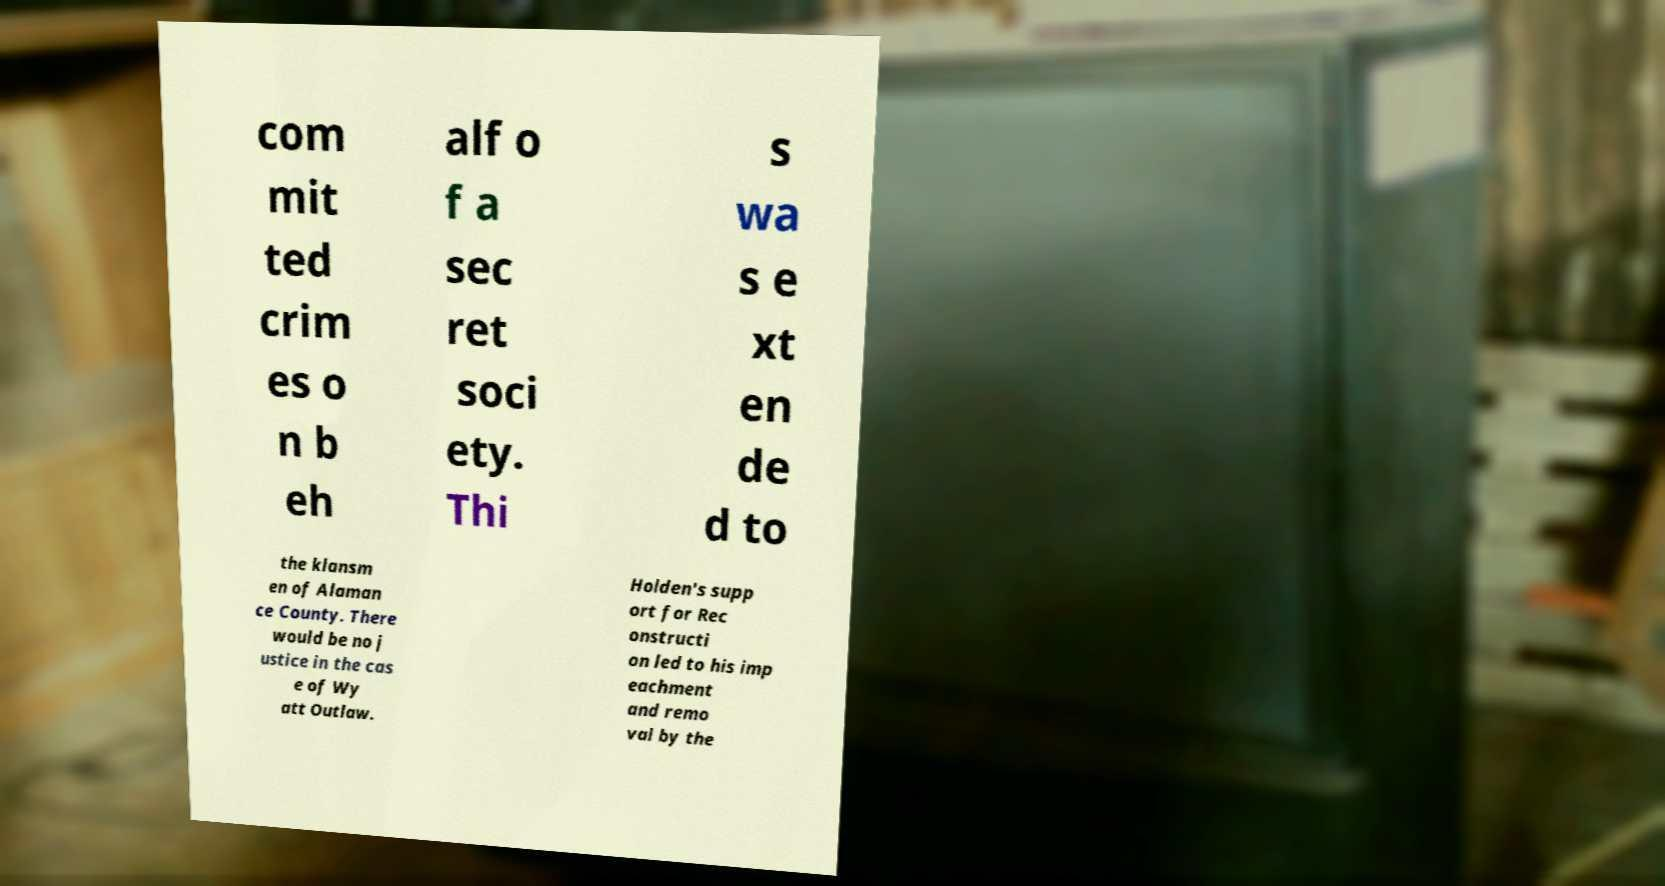I need the written content from this picture converted into text. Can you do that? com mit ted crim es o n b eh alf o f a sec ret soci ety. Thi s wa s e xt en de d to the klansm en of Alaman ce County. There would be no j ustice in the cas e of Wy att Outlaw. Holden's supp ort for Rec onstructi on led to his imp eachment and remo val by the 